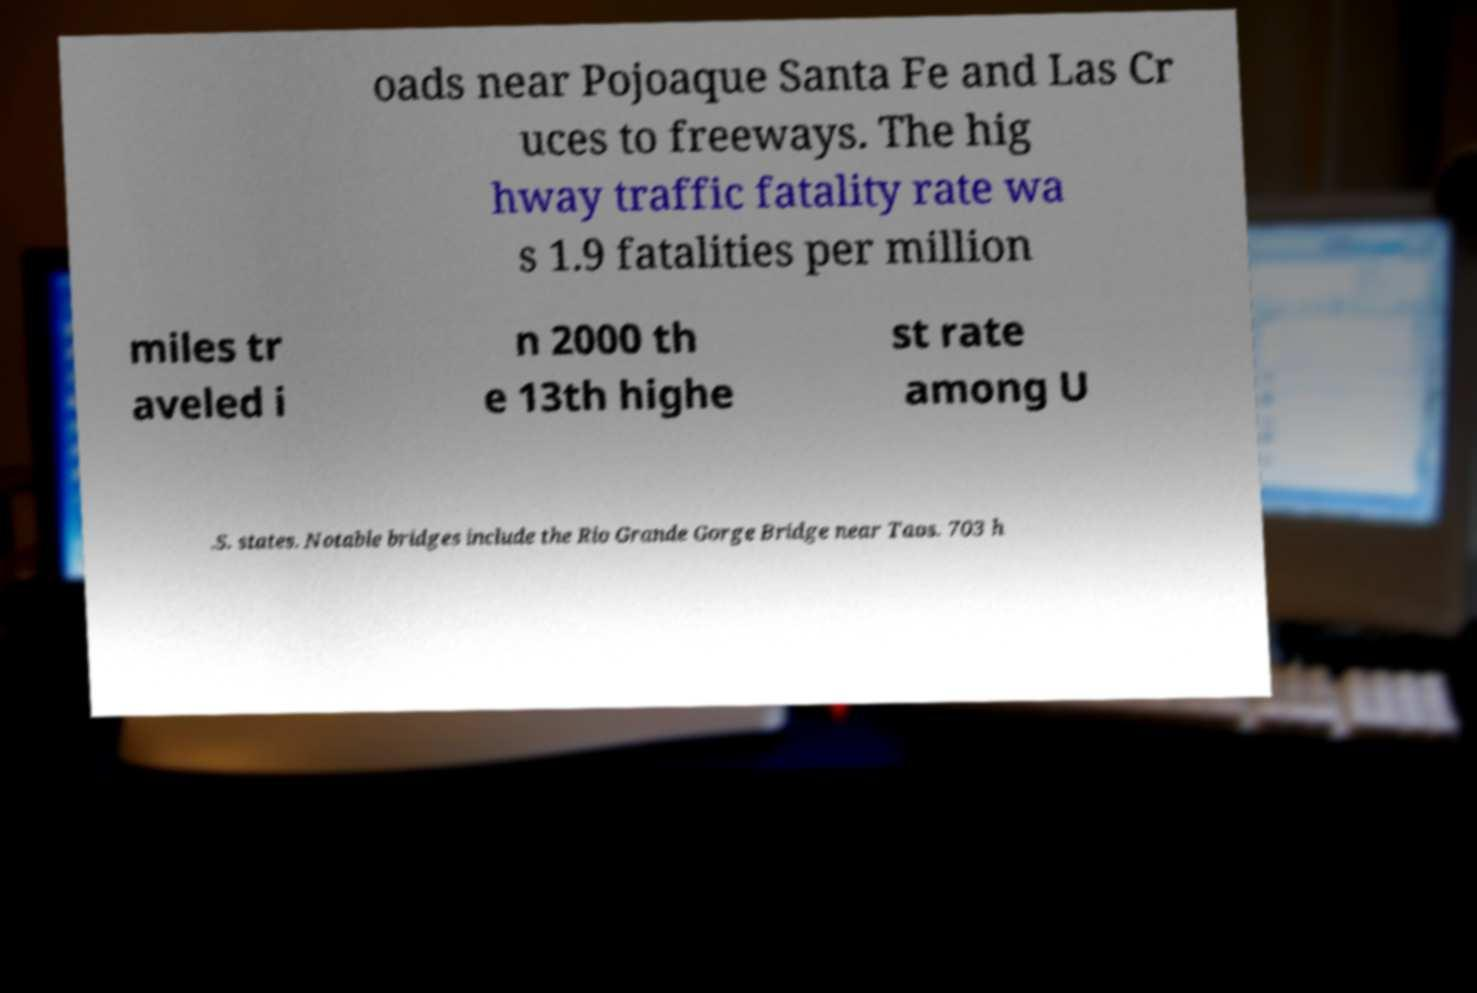Could you extract and type out the text from this image? oads near Pojoaque Santa Fe and Las Cr uces to freeways. The hig hway traffic fatality rate wa s 1.9 fatalities per million miles tr aveled i n 2000 th e 13th highe st rate among U .S. states. Notable bridges include the Rio Grande Gorge Bridge near Taos. 703 h 